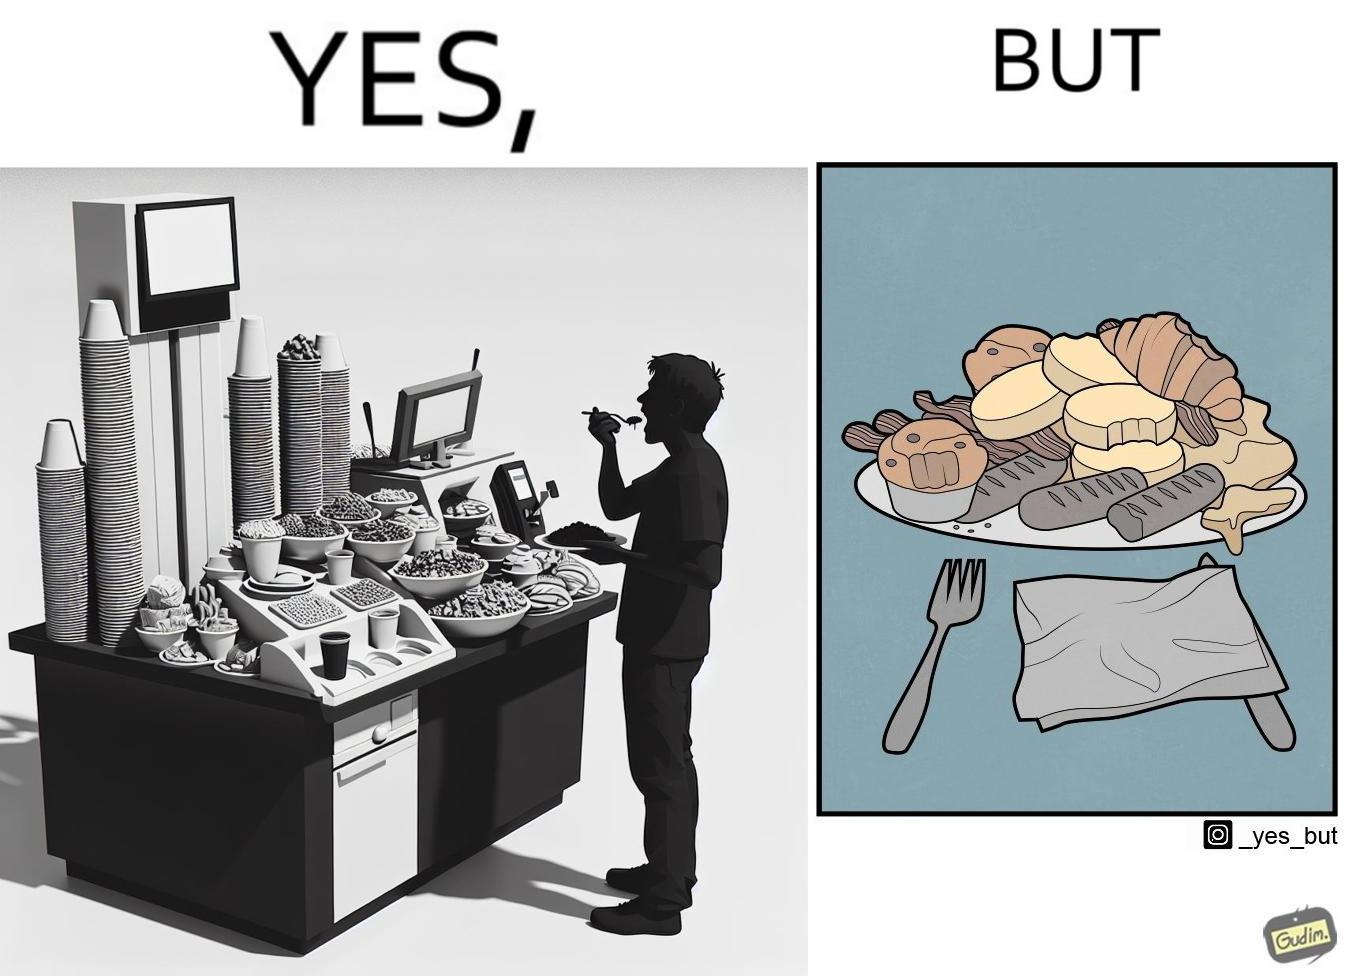What does this image depict? The image is satirical because while the man overfils his plate with differnt food items, he ends up wasting almost all of it by not eating them or by taking just one bite out of them leaving the rest. 